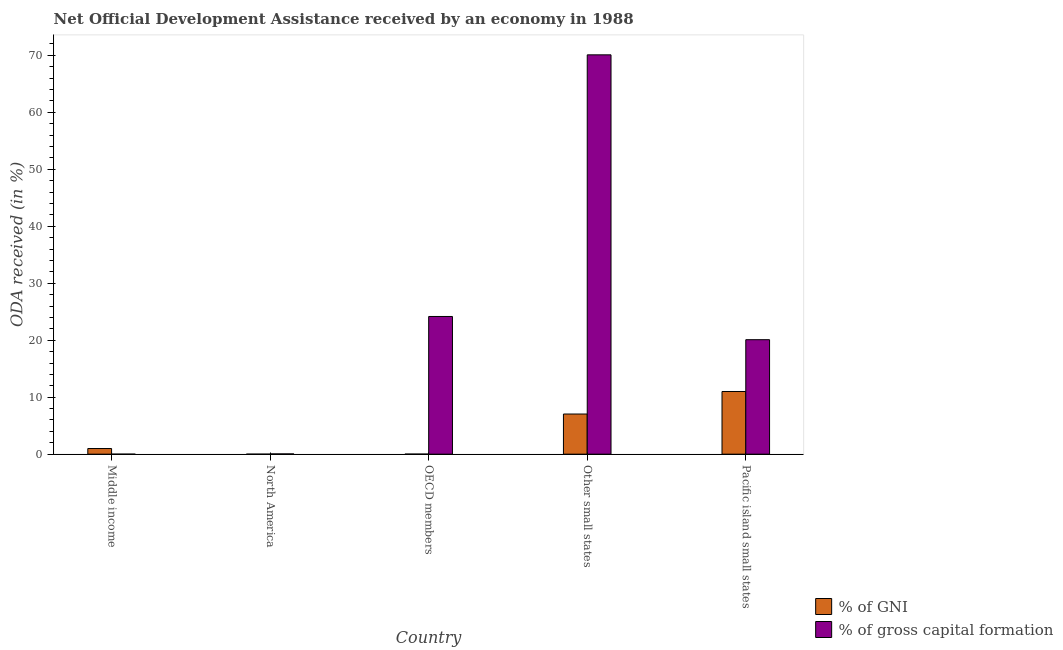How many different coloured bars are there?
Provide a short and direct response. 2. Are the number of bars per tick equal to the number of legend labels?
Ensure brevity in your answer.  Yes. What is the label of the 5th group of bars from the left?
Ensure brevity in your answer.  Pacific island small states. In how many cases, is the number of bars for a given country not equal to the number of legend labels?
Your response must be concise. 0. What is the oda received as percentage of gni in Other small states?
Give a very brief answer. 7.04. Across all countries, what is the maximum oda received as percentage of gni?
Keep it short and to the point. 11. Across all countries, what is the minimum oda received as percentage of gross capital formation?
Make the answer very short. 3.04033385865857e-6. In which country was the oda received as percentage of gross capital formation maximum?
Provide a succinct answer. Other small states. What is the total oda received as percentage of gross capital formation in the graph?
Give a very brief answer. 114.39. What is the difference between the oda received as percentage of gross capital formation in Middle income and that in Other small states?
Ensure brevity in your answer.  -70.09. What is the difference between the oda received as percentage of gross capital formation in OECD members and the oda received as percentage of gni in Other small states?
Provide a short and direct response. 17.12. What is the average oda received as percentage of gni per country?
Your answer should be very brief. 3.81. What is the difference between the oda received as percentage of gross capital formation and oda received as percentage of gni in North America?
Offer a terse response. 0.04. In how many countries, is the oda received as percentage of gni greater than 54 %?
Your answer should be very brief. 0. What is the ratio of the oda received as percentage of gni in OECD members to that in Other small states?
Provide a succinct answer. 0. Is the difference between the oda received as percentage of gni in North America and OECD members greater than the difference between the oda received as percentage of gross capital formation in North America and OECD members?
Provide a short and direct response. Yes. What is the difference between the highest and the second highest oda received as percentage of gross capital formation?
Keep it short and to the point. 45.92. What is the difference between the highest and the lowest oda received as percentage of gross capital formation?
Your answer should be very brief. 70.09. Is the sum of the oda received as percentage of gni in OECD members and Other small states greater than the maximum oda received as percentage of gross capital formation across all countries?
Your response must be concise. No. What does the 2nd bar from the left in Other small states represents?
Give a very brief answer. % of gross capital formation. What does the 1st bar from the right in OECD members represents?
Make the answer very short. % of gross capital formation. Are all the bars in the graph horizontal?
Ensure brevity in your answer.  No. How many countries are there in the graph?
Your answer should be very brief. 5. Are the values on the major ticks of Y-axis written in scientific E-notation?
Give a very brief answer. No. What is the title of the graph?
Offer a very short reply. Net Official Development Assistance received by an economy in 1988. What is the label or title of the X-axis?
Make the answer very short. Country. What is the label or title of the Y-axis?
Make the answer very short. ODA received (in %). What is the ODA received (in %) of % of GNI in Middle income?
Offer a terse response. 0.99. What is the ODA received (in %) of % of gross capital formation in Middle income?
Make the answer very short. 3.04033385865857e-6. What is the ODA received (in %) of % of GNI in North America?
Make the answer very short. 6.935147551222429e-7. What is the ODA received (in %) in % of gross capital formation in North America?
Your response must be concise. 0.04. What is the ODA received (in %) in % of GNI in OECD members?
Offer a terse response. 0.01. What is the ODA received (in %) in % of gross capital formation in OECD members?
Your response must be concise. 24.17. What is the ODA received (in %) of % of GNI in Other small states?
Ensure brevity in your answer.  7.04. What is the ODA received (in %) in % of gross capital formation in Other small states?
Make the answer very short. 70.09. What is the ODA received (in %) in % of GNI in Pacific island small states?
Ensure brevity in your answer.  11. What is the ODA received (in %) of % of gross capital formation in Pacific island small states?
Give a very brief answer. 20.09. Across all countries, what is the maximum ODA received (in %) of % of GNI?
Keep it short and to the point. 11. Across all countries, what is the maximum ODA received (in %) in % of gross capital formation?
Your answer should be compact. 70.09. Across all countries, what is the minimum ODA received (in %) of % of GNI?
Keep it short and to the point. 6.935147551222429e-7. Across all countries, what is the minimum ODA received (in %) in % of gross capital formation?
Offer a very short reply. 3.04033385865857e-6. What is the total ODA received (in %) in % of GNI in the graph?
Make the answer very short. 19.05. What is the total ODA received (in %) of % of gross capital formation in the graph?
Keep it short and to the point. 114.39. What is the difference between the ODA received (in %) in % of GNI in Middle income and that in North America?
Make the answer very short. 0.99. What is the difference between the ODA received (in %) in % of gross capital formation in Middle income and that in North America?
Keep it short and to the point. -0.04. What is the difference between the ODA received (in %) of % of GNI in Middle income and that in OECD members?
Your answer should be compact. 0.98. What is the difference between the ODA received (in %) of % of gross capital formation in Middle income and that in OECD members?
Provide a succinct answer. -24.17. What is the difference between the ODA received (in %) of % of GNI in Middle income and that in Other small states?
Offer a very short reply. -6.05. What is the difference between the ODA received (in %) of % of gross capital formation in Middle income and that in Other small states?
Ensure brevity in your answer.  -70.09. What is the difference between the ODA received (in %) of % of GNI in Middle income and that in Pacific island small states?
Offer a very short reply. -10.01. What is the difference between the ODA received (in %) in % of gross capital formation in Middle income and that in Pacific island small states?
Ensure brevity in your answer.  -20.09. What is the difference between the ODA received (in %) in % of GNI in North America and that in OECD members?
Offer a terse response. -0.01. What is the difference between the ODA received (in %) of % of gross capital formation in North America and that in OECD members?
Your response must be concise. -24.12. What is the difference between the ODA received (in %) of % of GNI in North America and that in Other small states?
Offer a very short reply. -7.04. What is the difference between the ODA received (in %) of % of gross capital formation in North America and that in Other small states?
Your answer should be compact. -70.04. What is the difference between the ODA received (in %) of % of GNI in North America and that in Pacific island small states?
Offer a terse response. -11. What is the difference between the ODA received (in %) in % of gross capital formation in North America and that in Pacific island small states?
Keep it short and to the point. -20.05. What is the difference between the ODA received (in %) in % of GNI in OECD members and that in Other small states?
Your answer should be compact. -7.03. What is the difference between the ODA received (in %) of % of gross capital formation in OECD members and that in Other small states?
Provide a succinct answer. -45.92. What is the difference between the ODA received (in %) of % of GNI in OECD members and that in Pacific island small states?
Offer a terse response. -10.99. What is the difference between the ODA received (in %) in % of gross capital formation in OECD members and that in Pacific island small states?
Provide a short and direct response. 4.08. What is the difference between the ODA received (in %) in % of GNI in Other small states and that in Pacific island small states?
Make the answer very short. -3.96. What is the difference between the ODA received (in %) in % of gross capital formation in Other small states and that in Pacific island small states?
Provide a short and direct response. 49.99. What is the difference between the ODA received (in %) in % of GNI in Middle income and the ODA received (in %) in % of gross capital formation in North America?
Offer a very short reply. 0.95. What is the difference between the ODA received (in %) of % of GNI in Middle income and the ODA received (in %) of % of gross capital formation in OECD members?
Provide a succinct answer. -23.18. What is the difference between the ODA received (in %) in % of GNI in Middle income and the ODA received (in %) in % of gross capital formation in Other small states?
Provide a succinct answer. -69.09. What is the difference between the ODA received (in %) of % of GNI in Middle income and the ODA received (in %) of % of gross capital formation in Pacific island small states?
Keep it short and to the point. -19.1. What is the difference between the ODA received (in %) of % of GNI in North America and the ODA received (in %) of % of gross capital formation in OECD members?
Provide a short and direct response. -24.17. What is the difference between the ODA received (in %) in % of GNI in North America and the ODA received (in %) in % of gross capital formation in Other small states?
Ensure brevity in your answer.  -70.09. What is the difference between the ODA received (in %) in % of GNI in North America and the ODA received (in %) in % of gross capital formation in Pacific island small states?
Offer a very short reply. -20.09. What is the difference between the ODA received (in %) of % of GNI in OECD members and the ODA received (in %) of % of gross capital formation in Other small states?
Your answer should be compact. -70.07. What is the difference between the ODA received (in %) of % of GNI in OECD members and the ODA received (in %) of % of gross capital formation in Pacific island small states?
Make the answer very short. -20.08. What is the difference between the ODA received (in %) in % of GNI in Other small states and the ODA received (in %) in % of gross capital formation in Pacific island small states?
Your answer should be compact. -13.05. What is the average ODA received (in %) in % of GNI per country?
Keep it short and to the point. 3.81. What is the average ODA received (in %) of % of gross capital formation per country?
Make the answer very short. 22.88. What is the difference between the ODA received (in %) of % of GNI and ODA received (in %) of % of gross capital formation in Middle income?
Your response must be concise. 0.99. What is the difference between the ODA received (in %) of % of GNI and ODA received (in %) of % of gross capital formation in North America?
Ensure brevity in your answer.  -0.04. What is the difference between the ODA received (in %) in % of GNI and ODA received (in %) in % of gross capital formation in OECD members?
Your answer should be compact. -24.16. What is the difference between the ODA received (in %) of % of GNI and ODA received (in %) of % of gross capital formation in Other small states?
Provide a short and direct response. -63.04. What is the difference between the ODA received (in %) of % of GNI and ODA received (in %) of % of gross capital formation in Pacific island small states?
Give a very brief answer. -9.09. What is the ratio of the ODA received (in %) in % of GNI in Middle income to that in North America?
Your response must be concise. 1.43e+06. What is the ratio of the ODA received (in %) in % of gross capital formation in Middle income to that in North America?
Offer a very short reply. 0. What is the ratio of the ODA received (in %) of % of GNI in Middle income to that in OECD members?
Offer a very short reply. 89.62. What is the ratio of the ODA received (in %) of % of gross capital formation in Middle income to that in OECD members?
Your answer should be very brief. 0. What is the ratio of the ODA received (in %) of % of GNI in Middle income to that in Other small states?
Ensure brevity in your answer.  0.14. What is the ratio of the ODA received (in %) in % of gross capital formation in Middle income to that in Other small states?
Give a very brief answer. 0. What is the ratio of the ODA received (in %) in % of GNI in Middle income to that in Pacific island small states?
Provide a short and direct response. 0.09. What is the ratio of the ODA received (in %) in % of gross capital formation in Middle income to that in Pacific island small states?
Your response must be concise. 0. What is the ratio of the ODA received (in %) in % of GNI in North America to that in OECD members?
Your answer should be very brief. 0. What is the ratio of the ODA received (in %) of % of gross capital formation in North America to that in OECD members?
Your response must be concise. 0. What is the ratio of the ODA received (in %) in % of gross capital formation in North America to that in Other small states?
Offer a terse response. 0. What is the ratio of the ODA received (in %) of % of gross capital formation in North America to that in Pacific island small states?
Make the answer very short. 0. What is the ratio of the ODA received (in %) of % of GNI in OECD members to that in Other small states?
Offer a very short reply. 0. What is the ratio of the ODA received (in %) of % of gross capital formation in OECD members to that in Other small states?
Ensure brevity in your answer.  0.34. What is the ratio of the ODA received (in %) in % of gross capital formation in OECD members to that in Pacific island small states?
Your answer should be compact. 1.2. What is the ratio of the ODA received (in %) in % of GNI in Other small states to that in Pacific island small states?
Keep it short and to the point. 0.64. What is the ratio of the ODA received (in %) of % of gross capital formation in Other small states to that in Pacific island small states?
Your answer should be compact. 3.49. What is the difference between the highest and the second highest ODA received (in %) in % of GNI?
Make the answer very short. 3.96. What is the difference between the highest and the second highest ODA received (in %) of % of gross capital formation?
Your response must be concise. 45.92. What is the difference between the highest and the lowest ODA received (in %) in % of GNI?
Offer a very short reply. 11. What is the difference between the highest and the lowest ODA received (in %) of % of gross capital formation?
Your response must be concise. 70.09. 